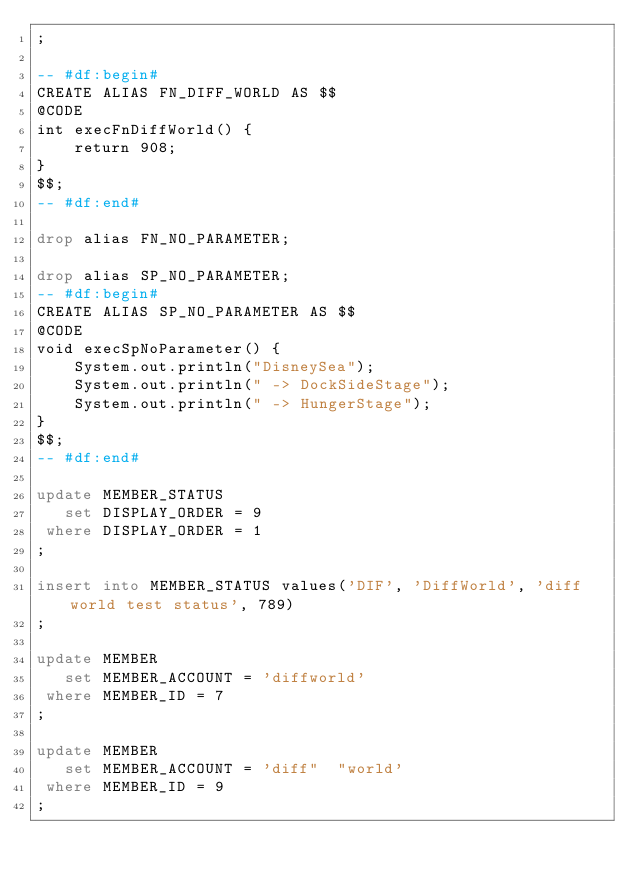Convert code to text. <code><loc_0><loc_0><loc_500><loc_500><_SQL_>;

-- #df:begin#
CREATE ALIAS FN_DIFF_WORLD AS $$
@CODE 
int execFnDiffWorld() {
    return 908;
}
$$;
-- #df:end#

drop alias FN_NO_PARAMETER;

drop alias SP_NO_PARAMETER;
-- #df:begin#
CREATE ALIAS SP_NO_PARAMETER AS $$
@CODE
void execSpNoParameter() {
    System.out.println("DisneySea");
    System.out.println(" -> DockSideStage");
    System.out.println(" -> HungerStage");
}
$$;
-- #df:end#

update MEMBER_STATUS
   set DISPLAY_ORDER = 9
 where DISPLAY_ORDER = 1
;

insert into MEMBER_STATUS values('DIF', 'DiffWorld', 'diff world test status', 789)
;

update MEMBER
   set MEMBER_ACCOUNT = 'diffworld'
 where MEMBER_ID = 7
;

update MEMBER
   set MEMBER_ACCOUNT = 'diff"	"world'
 where MEMBER_ID = 9
;
</code> 